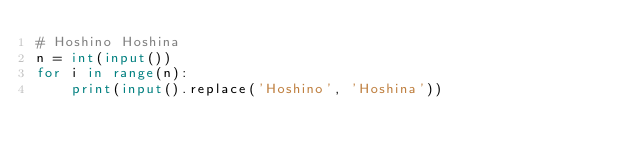<code> <loc_0><loc_0><loc_500><loc_500><_Python_># Hoshino Hoshina
n = int(input())
for i in range(n):
    print(input().replace('Hoshino', 'Hoshina'))
</code> 